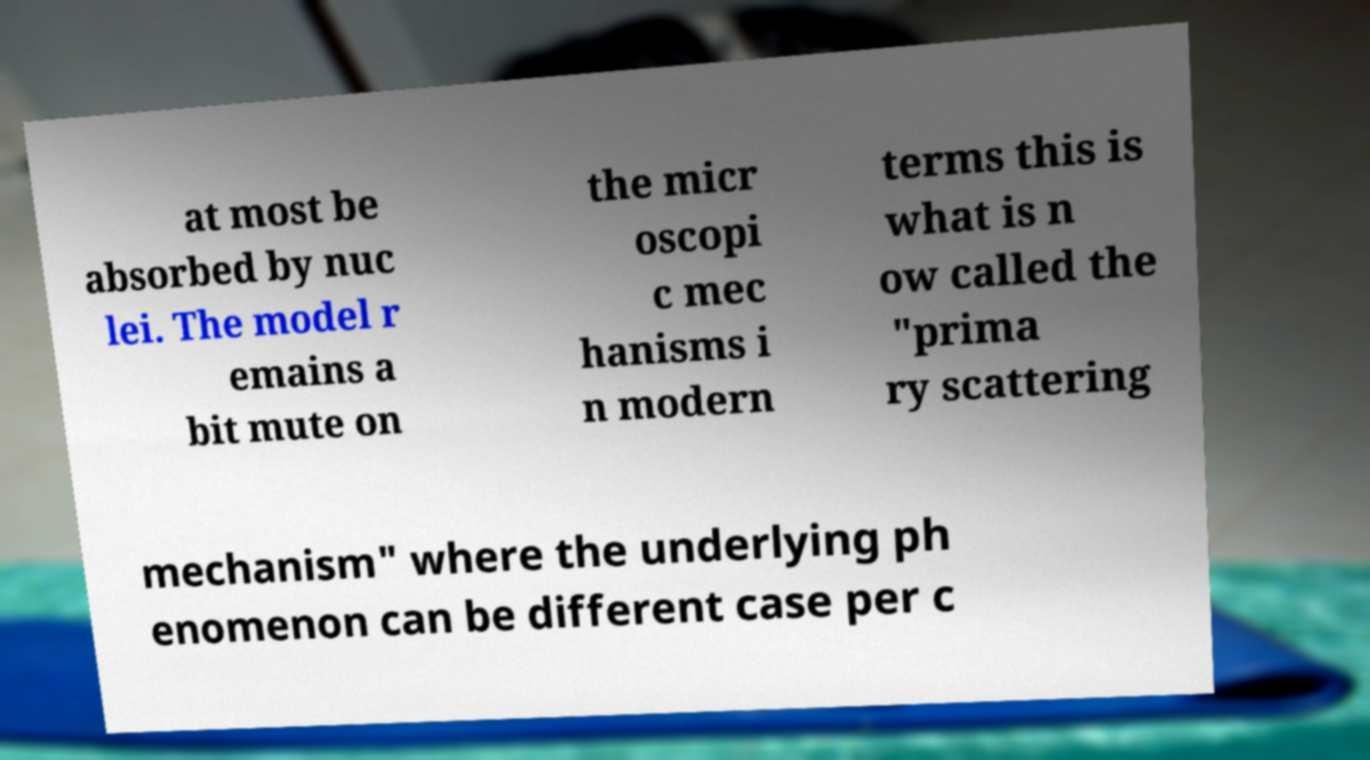What messages or text are displayed in this image? I need them in a readable, typed format. at most be absorbed by nuc lei. The model r emains a bit mute on the micr oscopi c mec hanisms i n modern terms this is what is n ow called the "prima ry scattering mechanism" where the underlying ph enomenon can be different case per c 